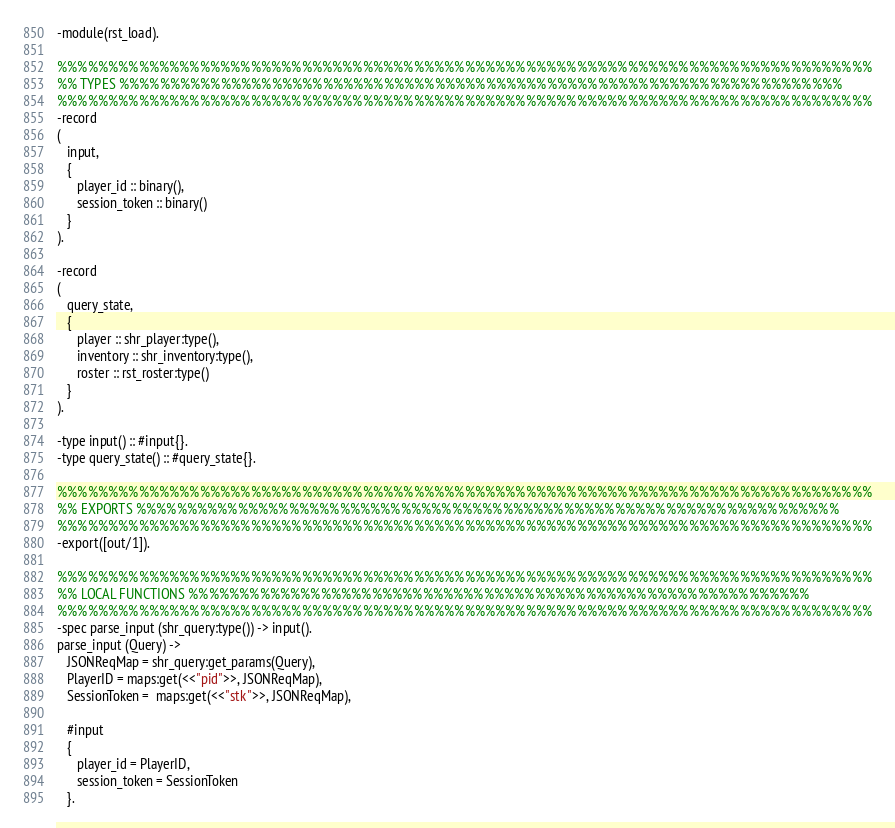Convert code to text. <code><loc_0><loc_0><loc_500><loc_500><_Erlang_>-module(rst_load).

%%%%%%%%%%%%%%%%%%%%%%%%%%%%%%%%%%%%%%%%%%%%%%%%%%%%%%%%%%%%%%%%%%%%%%%%%%%%%%%%
%% TYPES %%%%%%%%%%%%%%%%%%%%%%%%%%%%%%%%%%%%%%%%%%%%%%%%%%%%%%%%%%%%%%%%%%%%%%%
%%%%%%%%%%%%%%%%%%%%%%%%%%%%%%%%%%%%%%%%%%%%%%%%%%%%%%%%%%%%%%%%%%%%%%%%%%%%%%%%
-record
(
   input,
   {
      player_id :: binary(),
      session_token :: binary()
   }
).

-record
(
   query_state,
   {
      player :: shr_player:type(),
      inventory :: shr_inventory:type(),
      roster :: rst_roster:type()
   }
).

-type input() :: #input{}.
-type query_state() :: #query_state{}.

%%%%%%%%%%%%%%%%%%%%%%%%%%%%%%%%%%%%%%%%%%%%%%%%%%%%%%%%%%%%%%%%%%%%%%%%%%%%%%%%
%% EXPORTS %%%%%%%%%%%%%%%%%%%%%%%%%%%%%%%%%%%%%%%%%%%%%%%%%%%%%%%%%%%%%%%%%%%%%
%%%%%%%%%%%%%%%%%%%%%%%%%%%%%%%%%%%%%%%%%%%%%%%%%%%%%%%%%%%%%%%%%%%%%%%%%%%%%%%%
-export([out/1]).

%%%%%%%%%%%%%%%%%%%%%%%%%%%%%%%%%%%%%%%%%%%%%%%%%%%%%%%%%%%%%%%%%%%%%%%%%%%%%%%%
%% LOCAL FUNCTIONS %%%%%%%%%%%%%%%%%%%%%%%%%%%%%%%%%%%%%%%%%%%%%%%%%%%%%%%%%%%%%
%%%%%%%%%%%%%%%%%%%%%%%%%%%%%%%%%%%%%%%%%%%%%%%%%%%%%%%%%%%%%%%%%%%%%%%%%%%%%%%%
-spec parse_input (shr_query:type()) -> input().
parse_input (Query) ->
   JSONReqMap = shr_query:get_params(Query),
   PlayerID = maps:get(<<"pid">>, JSONReqMap),
   SessionToken =  maps:get(<<"stk">>, JSONReqMap),

   #input
   {
      player_id = PlayerID,
      session_token = SessionToken
   }.
</code> 